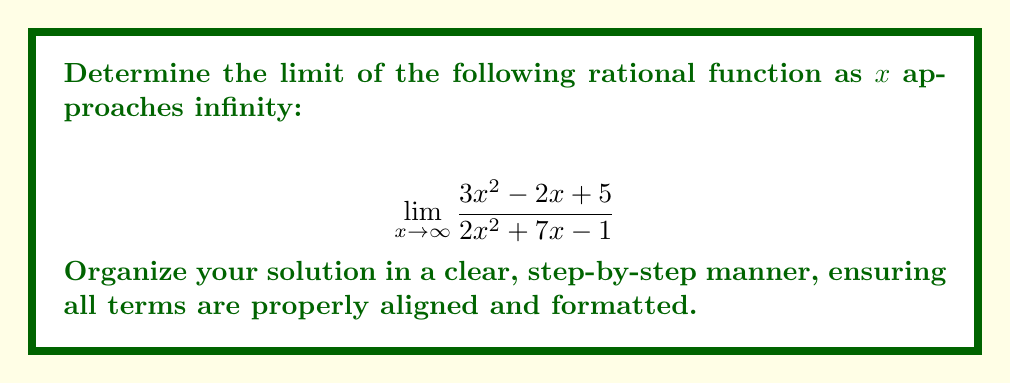Help me with this question. To find the limit of a rational function as $x$ approaches infinity, we follow these steps:

1) Identify the highest degree terms in both numerator and denominator:
   Numerator: $3x^2$
   Denominator: $2x^2$

2) Divide both numerator and denominator by the highest degree term ($x^2$):

   $$\lim_{x \to \infty} \frac{3x^2 - 2x + 5}{2x^2 + 7x - 1} = \lim_{x \to \infty} \frac{3 - \frac{2}{x} + \frac{5}{x^2}}{2 + \frac{7}{x} - \frac{1}{x^2}}$$

3) As $x$ approaches infinity, the terms with $\frac{1}{x}$ and $\frac{1}{x^2}$ approach 0:

   $$\lim_{x \to \infty} \frac{3 - 0 + 0}{2 + 0 - 0} = \frac{3}{2}$$

4) Simplify the final result:
   
   $$\frac{3}{2} = 1.5$$

Therefore, the limit of the rational function as $x$ approaches infinity is $\frac{3}{2}$ or 1.5.
Answer: $\frac{3}{2}$ 